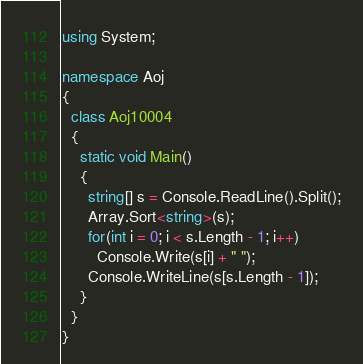Convert code to text. <code><loc_0><loc_0><loc_500><loc_500><_C#_>using System;

namespace Aoj
{
  class Aoj10004
  {
    static void Main()
    {
      string[] s = Console.ReadLine().Split();
      Array.Sort<string>(s);
      for(int i = 0; i < s.Length - 1; i++)
        Console.Write(s[i] + " ");
      Console.WriteLine(s[s.Length - 1]);
    }
  }
}</code> 